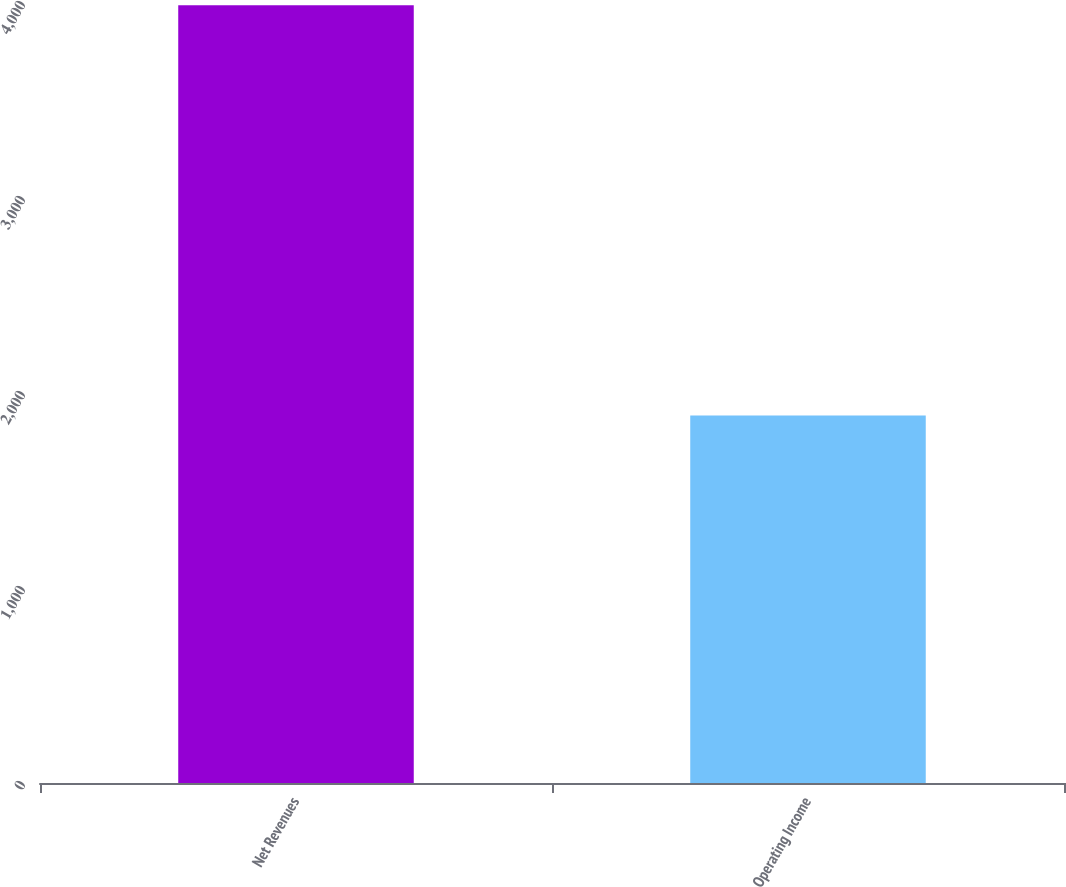Convert chart. <chart><loc_0><loc_0><loc_500><loc_500><bar_chart><fcel>Net Revenues<fcel>Operating Income<nl><fcel>3988<fcel>1884<nl></chart> 